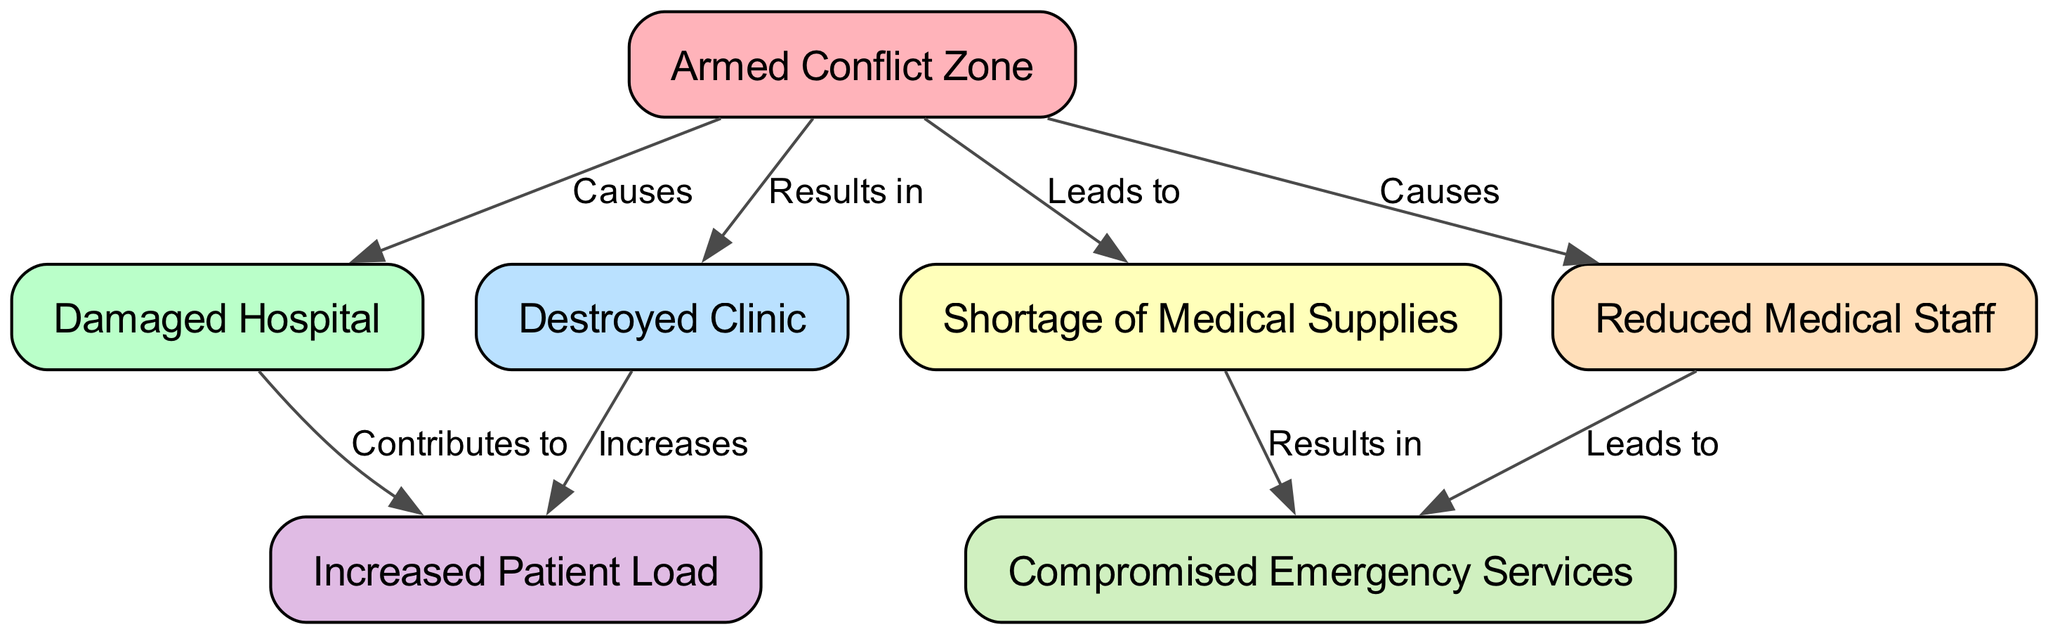What is the total number of nodes in the diagram? The diagram comprises a total of 7 nodes representing different elements related to armed conflict impact on healthcare infrastructure.
Answer: 7 Which node shows the result of armed conflict causing damage? The diagram indicates that the "Damaged Hospital" node results from the "Armed Conflict Zone" node, as illustrated by the directed edge labeled "Causes."
Answer: Damaged Hospital What leads to a shortage of medical supplies? The diagram indicates that the "Armed Conflict Zone" leads to a "Shortage of Medical Supplies," as shown by the directed edge linking these two nodes with the label "Leads to."
Answer: Armed Conflict Zone Which two nodes are linked by the edge labeled "Contributes to"? The "Damaged Hospital" contributes to an "Increased Patient Load," as evidenced by the edge labeled "Contributes to" connecting these two nodes.
Answer: Increased Patient Load What node results from both damaged facilities and reduced medical staff? The "Compromised Emergency Services" node results from the influences of both the "Shortage of Medical Supplies" and the "Reduced Medical Staff," as seen in their respective edges labeled "Results in" and "Leads to."
Answer: Compromised Emergency Services How many edges are in the diagram? The diagram consists of 8 edges that illustrate relationships between the nodes, indicating the connections and flows of influence regarding healthcare infrastructure during armed conflict.
Answer: 8 What is the relationship between the "Destroyed Clinic" and the "Increased Patient Load"? The "Destroyed Clinic" directly increases the "Increased Patient Load" through the edge that connects them and is labeled "Increases."
Answer: Increases Which node describes the impact of armed conflict on emergency services? The "Compromised Emergency Services" node describes the impact resulting from both a "Shortage of Medical Supplies" and "Reduced Medical Staff," showing how conflict can degrade emergency care capabilities.
Answer: Compromised Emergency Services 